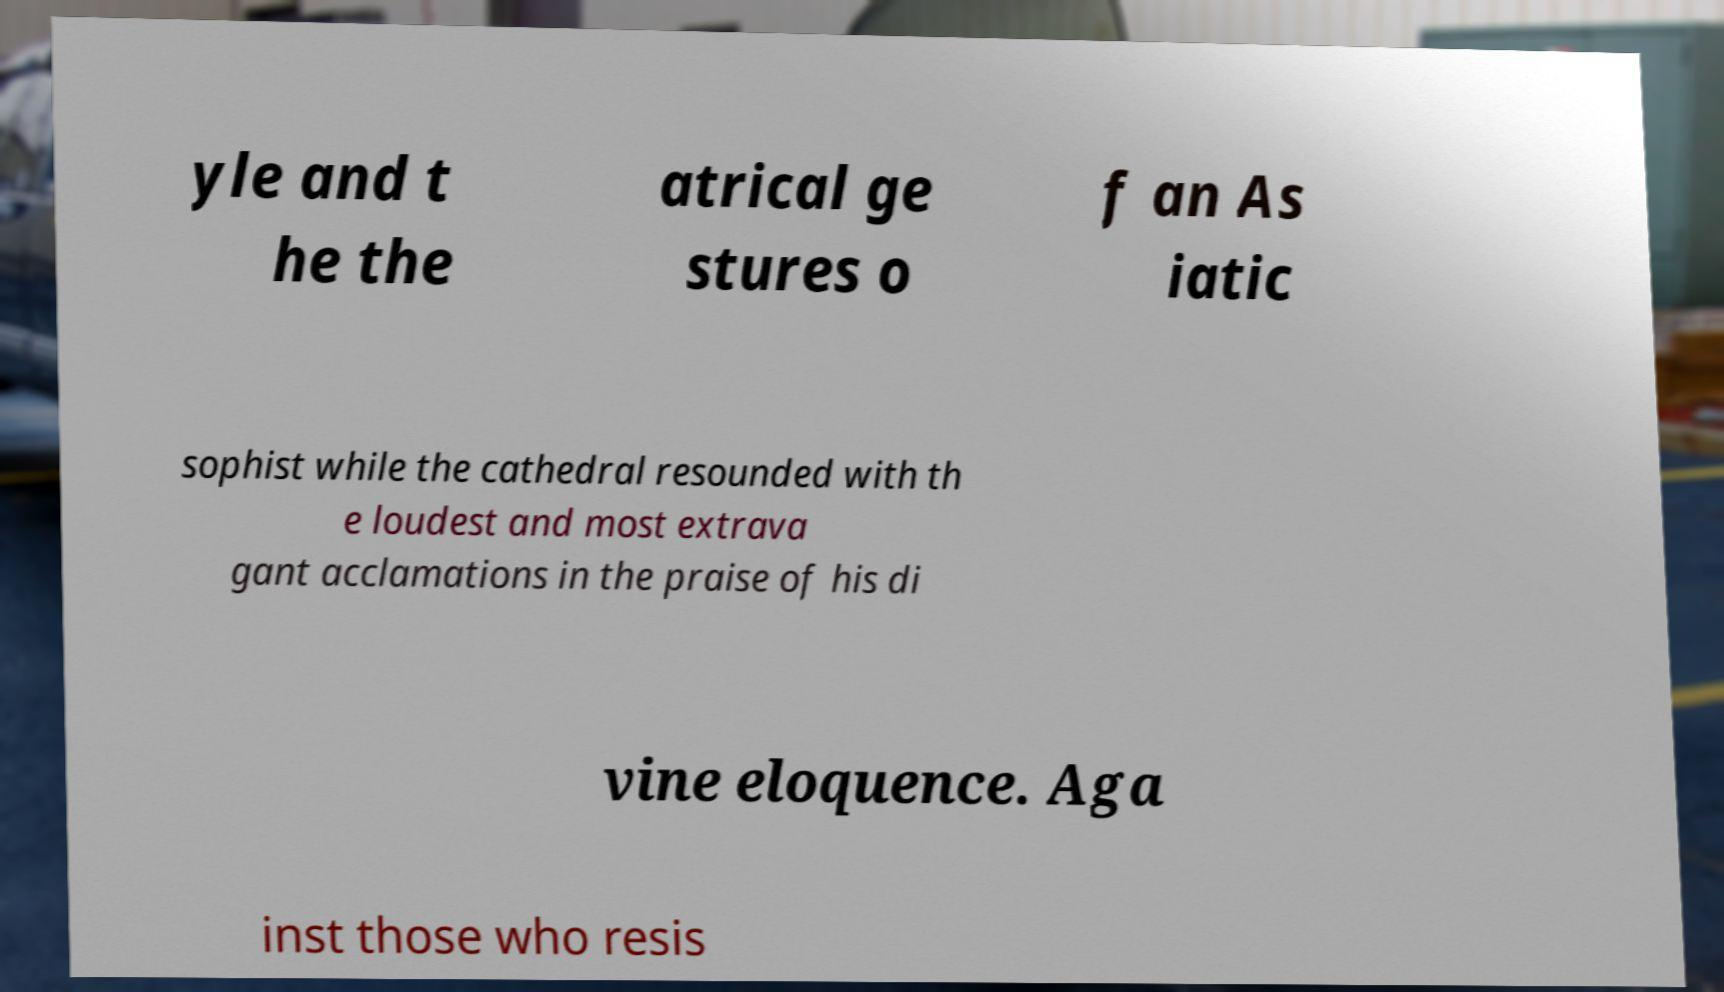Could you assist in decoding the text presented in this image and type it out clearly? yle and t he the atrical ge stures o f an As iatic sophist while the cathedral resounded with th e loudest and most extrava gant acclamations in the praise of his di vine eloquence. Aga inst those who resis 